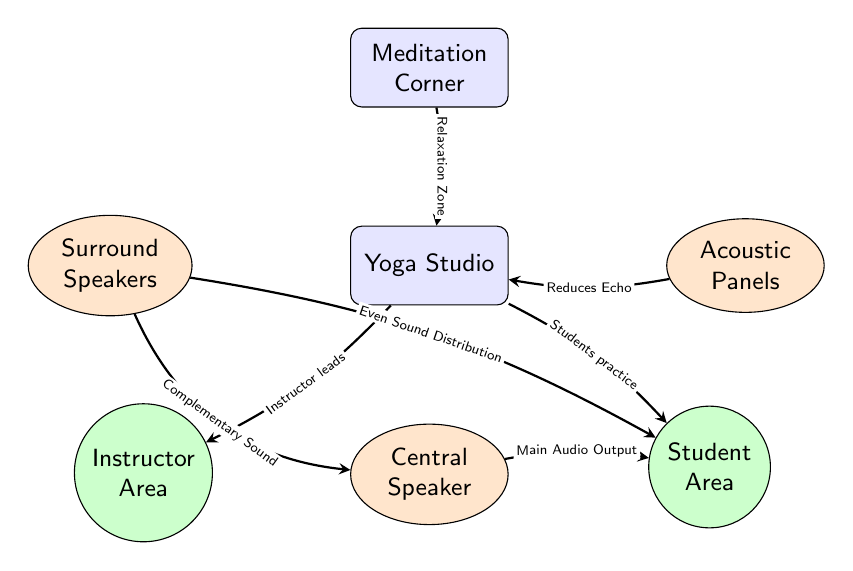What is the main function of the Central Speaker? The Central Speaker is indicated as the node that provides the "Main Audio Output" to the student area. This shows its primary function is to distribute audio sound throughout the studio.
Answer: Main Audio Output How many areas are designated for instructors and students? The diagram clearly indicates two areas labeled: "Instructor Area" and "Student Area," which indicate the spatial designations for these groups.
Answer: Two areas What is the relationship between the Surround Speakers and Student Area? The Surround Speakers node points to the Student Area node with a label that indicates they provide "Even Sound Distribution," signifying a direct functional relationship.
Answer: Even Sound Distribution Which component is identified as reducing echo in the studio? The diagram shows Acoustic Panels as the component that links to the Yoga Studio and is labeled as performing the function of "Reduces Echo."
Answer: Acoustic Panels What does the Meditation Corner provide to the Yoga Studio? The Meditation Corner points toward the Yoga Studio with the label "Relaxation Zone," indicating that it serves as a space that contributes to relaxation within the studio setting.
Answer: Relaxation Zone What is the function of the arrow linking the Surround Speakers to the Central Speaker? The arrow connecting these two nodes is labeled "Complementary Sound," which indicates that Surround Speakers work with the Central Speaker to enhance the overall auditory experience.
Answer: Complementary Sound How many nodes represent teacher and student areas in the diagram? The diagram distinctly features one node for the instructor and one node for the student, amounting to two different functional areas represented as circles.
Answer: Two nodes What are the shapes used for the Instructor and Student Areas? Both the Instructor Area and Student Area are represented as circles in the diagram. This indicates a balanced, central shape often associated with community and inclusiveness.
Answer: Circles What do Acoustic Panels reduce, as indicated in the diagram? As per the label connected to Acoustic Panels, they are designed to "Reduces Echo," emphasizing their role in improving acoustic quality in the studio.
Answer: Echo 